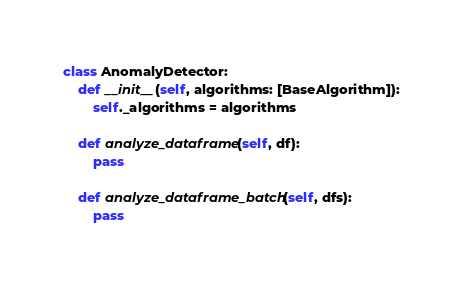<code> <loc_0><loc_0><loc_500><loc_500><_Python_>

class AnomalyDetector:
    def __init__(self, algorithms: [BaseAlgorithm]):
        self._algorithms = algorithms

    def analyze_dataframe(self, df):
        pass

    def analyze_dataframe_batch(self, dfs):
        pass
</code> 